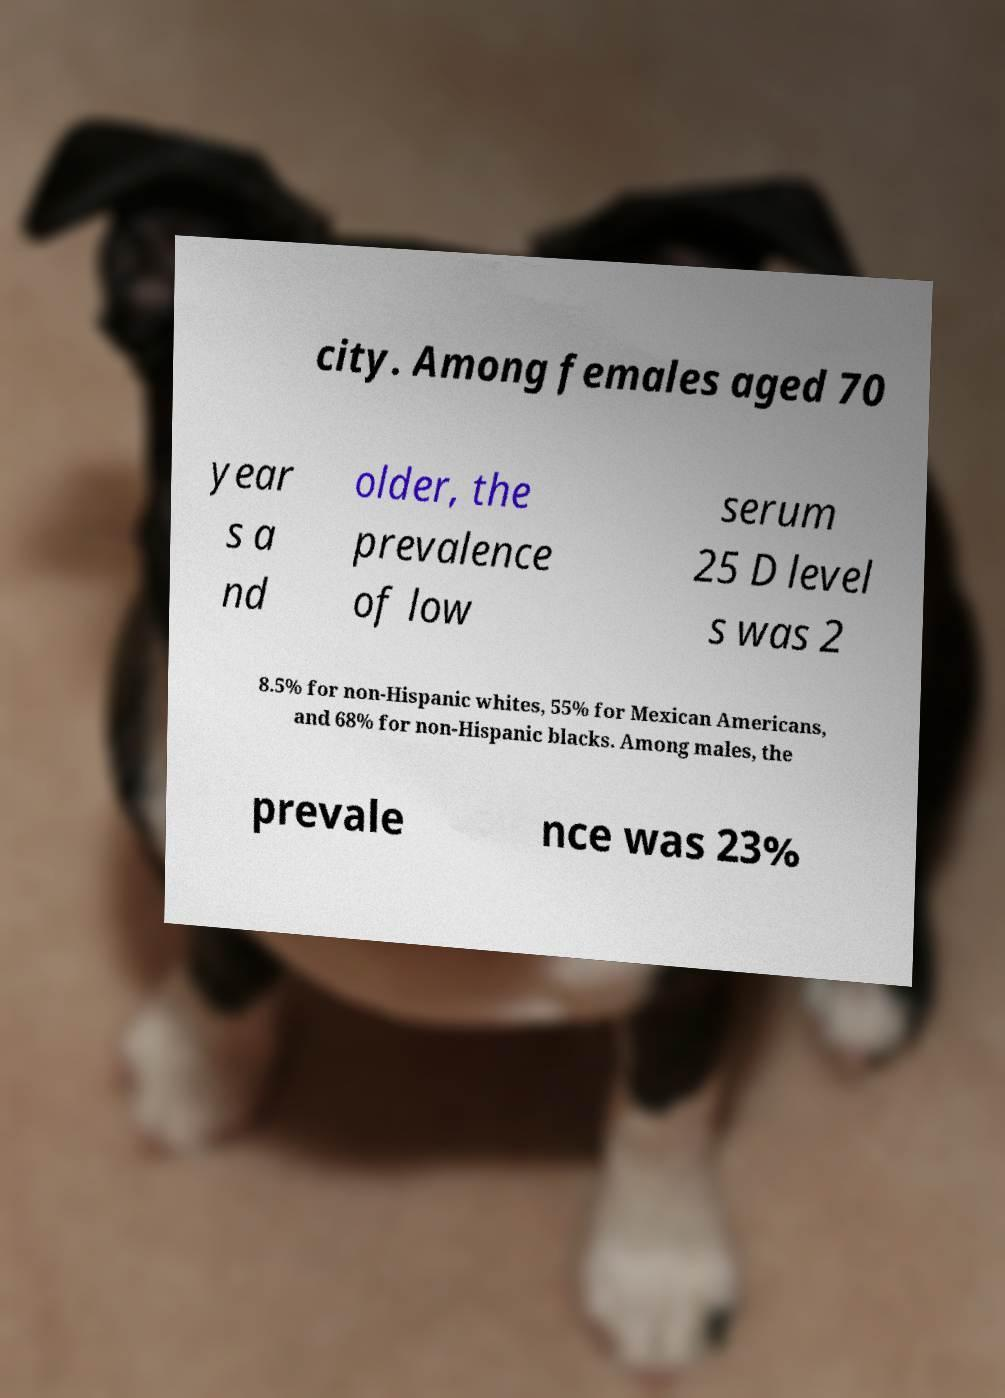Please read and relay the text visible in this image. What does it say? city. Among females aged 70 year s a nd older, the prevalence of low serum 25 D level s was 2 8.5% for non-Hispanic whites, 55% for Mexican Americans, and 68% for non-Hispanic blacks. Among males, the prevale nce was 23% 